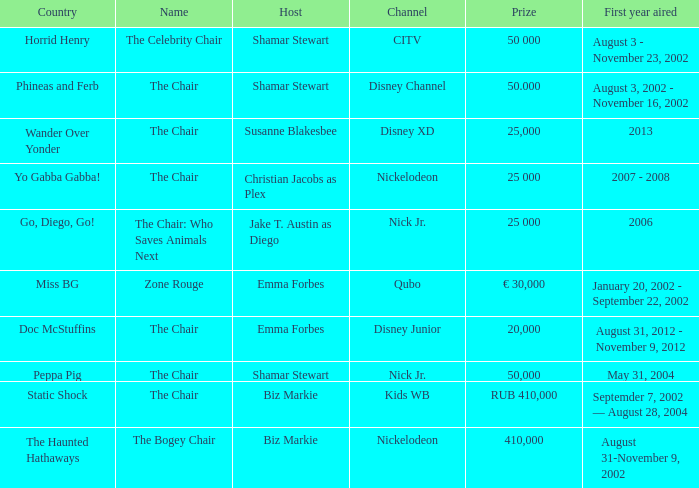What year did Zone Rouge first air? January 20, 2002 - September 22, 2002. Would you mind parsing the complete table? {'header': ['Country', 'Name', 'Host', 'Channel', 'Prize', 'First year aired'], 'rows': [['Horrid Henry', 'The Celebrity Chair', 'Shamar Stewart', 'CITV', '50 000', 'August 3 - November 23, 2002'], ['Phineas and Ferb', 'The Chair', 'Shamar Stewart', 'Disney Channel', '50.000', 'August 3, 2002 - November 16, 2002'], ['Wander Over Yonder', 'The Chair', 'Susanne Blakesbee', 'Disney XD', '25,000', '2013'], ['Yo Gabba Gabba!', 'The Chair', 'Christian Jacobs as Plex', 'Nickelodeon', '25 000', '2007 - 2008'], ['Go, Diego, Go!', 'The Chair: Who Saves Animals Next', 'Jake T. Austin as Diego', 'Nick Jr.', '25 000', '2006'], ['Miss BG', 'Zone Rouge', 'Emma Forbes', 'Qubo', '€ 30,000', 'January 20, 2002 - September 22, 2002'], ['Doc McStuffins', 'The Chair', 'Emma Forbes', 'Disney Junior', '20,000', 'August 31, 2012 - November 9, 2012'], ['Peppa Pig', 'The Chair', 'Shamar Stewart', 'Nick Jr.', '50,000', 'May 31, 2004'], ['Static Shock', 'The Chair', 'Biz Markie', 'Kids WB', 'RUB 410,000', 'Septemder 7, 2002 — August 28, 2004'], ['The Haunted Hathaways', 'The Bogey Chair', 'Biz Markie', 'Nickelodeon', '410,000', 'August 31-November 9, 2002']]} 